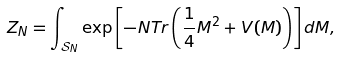Convert formula to latex. <formula><loc_0><loc_0><loc_500><loc_500>Z _ { N } = \int _ { \mathcal { S } _ { N } } \exp \left [ - N T r \left ( \frac { 1 } { 4 } M ^ { 2 } + V ( M ) \right ) \right ] d M ,</formula> 